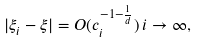Convert formula to latex. <formula><loc_0><loc_0><loc_500><loc_500>| \xi _ { i } - \xi | = O ( c _ { i } ^ { - 1 - \frac { 1 } { d } } ) \, i \to \infty ,</formula> 